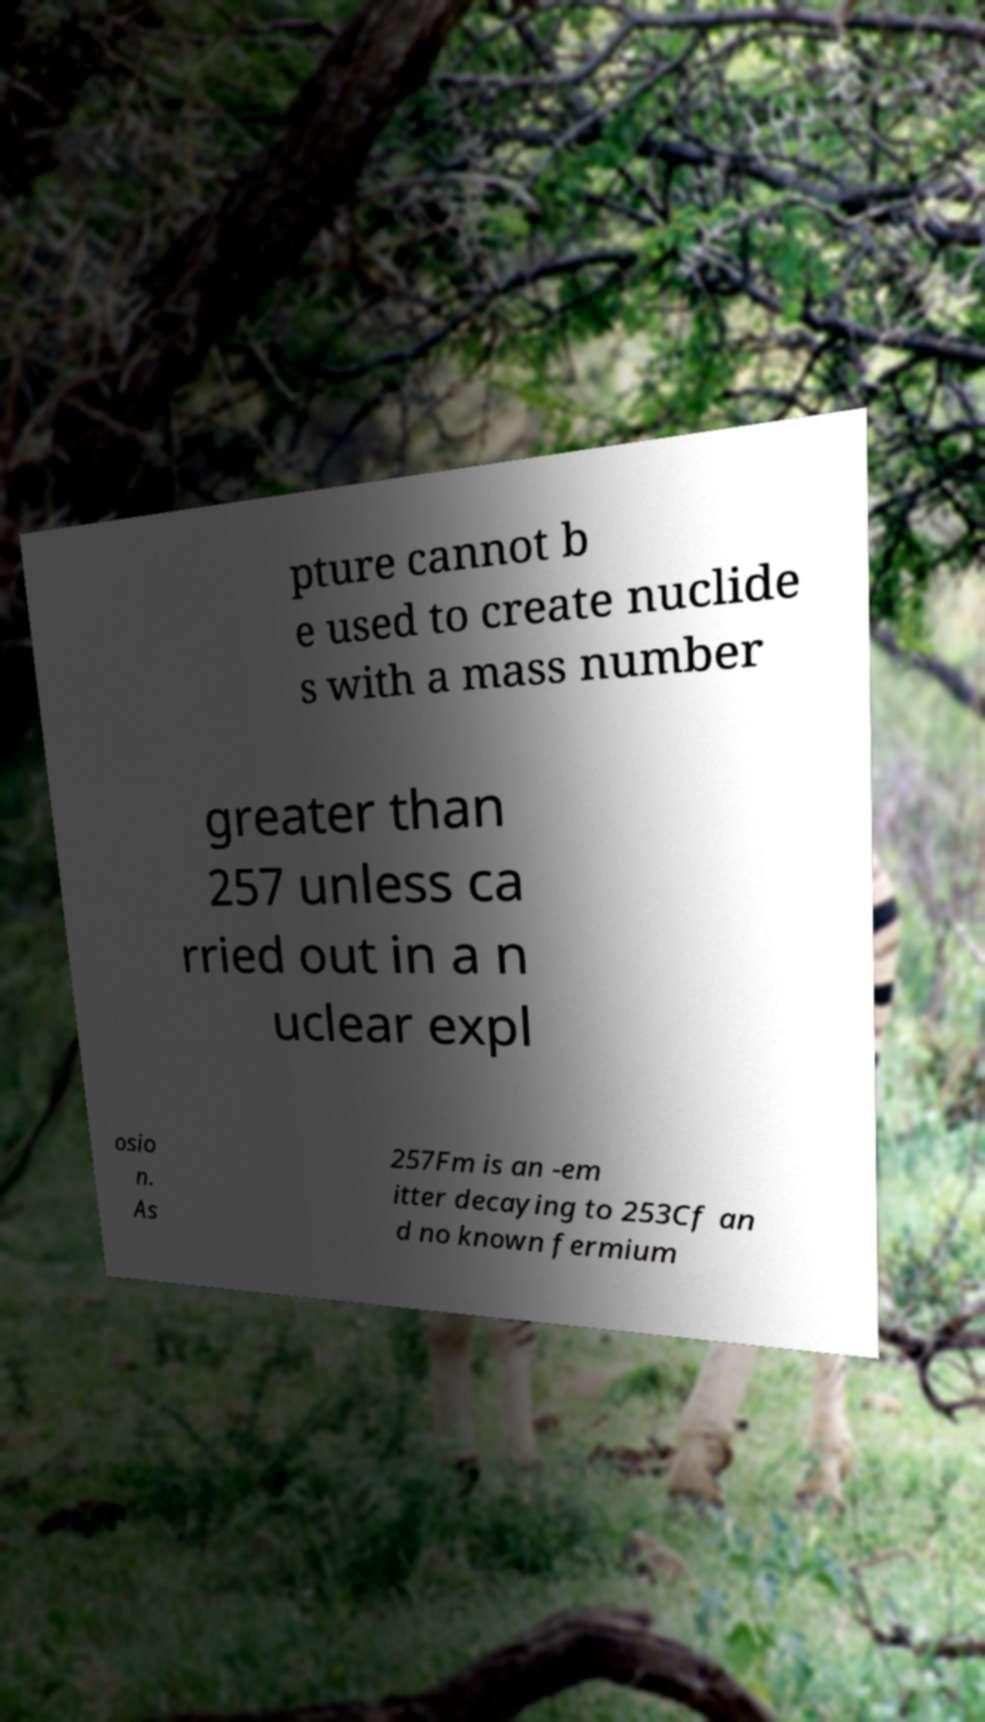Could you assist in decoding the text presented in this image and type it out clearly? pture cannot b e used to create nuclide s with a mass number greater than 257 unless ca rried out in a n uclear expl osio n. As 257Fm is an -em itter decaying to 253Cf an d no known fermium 